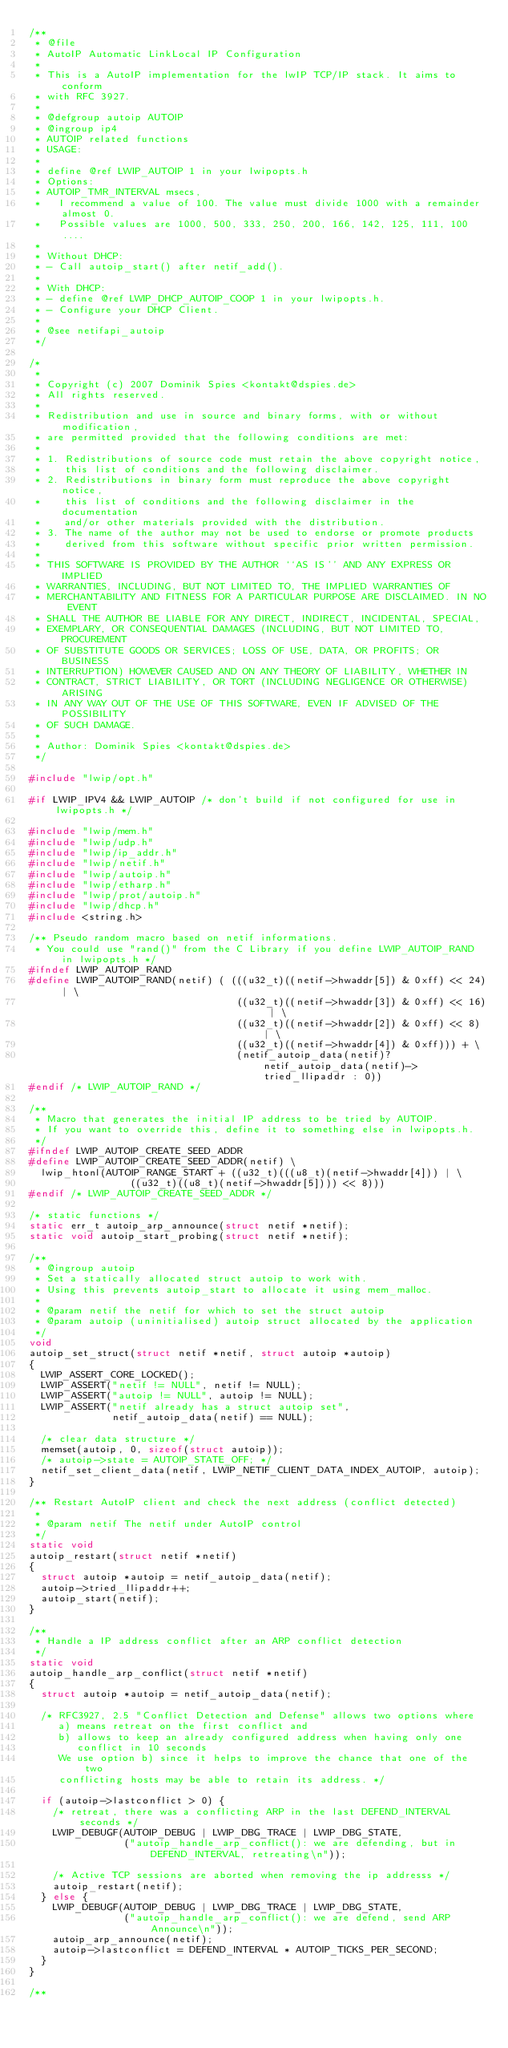<code> <loc_0><loc_0><loc_500><loc_500><_C_>/**
 * @file
 * AutoIP Automatic LinkLocal IP Configuration
 *
 * This is a AutoIP implementation for the lwIP TCP/IP stack. It aims to conform
 * with RFC 3927.
 *
 * @defgroup autoip AUTOIP
 * @ingroup ip4
 * AUTOIP related functions
 * USAGE:
 *
 * define @ref LWIP_AUTOIP 1 in your lwipopts.h
 * Options:
 * AUTOIP_TMR_INTERVAL msecs,
 *   I recommend a value of 100. The value must divide 1000 with a remainder almost 0.
 *   Possible values are 1000, 500, 333, 250, 200, 166, 142, 125, 111, 100 ....
 *
 * Without DHCP:
 * - Call autoip_start() after netif_add().
 *
 * With DHCP:
 * - define @ref LWIP_DHCP_AUTOIP_COOP 1 in your lwipopts.h.
 * - Configure your DHCP Client.
 *
 * @see netifapi_autoip
 */

/*
 *
 * Copyright (c) 2007 Dominik Spies <kontakt@dspies.de>
 * All rights reserved.
 *
 * Redistribution and use in source and binary forms, with or without modification,
 * are permitted provided that the following conditions are met:
 *
 * 1. Redistributions of source code must retain the above copyright notice,
 *    this list of conditions and the following disclaimer.
 * 2. Redistributions in binary form must reproduce the above copyright notice,
 *    this list of conditions and the following disclaimer in the documentation
 *    and/or other materials provided with the distribution.
 * 3. The name of the author may not be used to endorse or promote products
 *    derived from this software without specific prior written permission.
 *
 * THIS SOFTWARE IS PROVIDED BY THE AUTHOR ``AS IS'' AND ANY EXPRESS OR IMPLIED
 * WARRANTIES, INCLUDING, BUT NOT LIMITED TO, THE IMPLIED WARRANTIES OF
 * MERCHANTABILITY AND FITNESS FOR A PARTICULAR PURPOSE ARE DISCLAIMED. IN NO EVENT
 * SHALL THE AUTHOR BE LIABLE FOR ANY DIRECT, INDIRECT, INCIDENTAL, SPECIAL,
 * EXEMPLARY, OR CONSEQUENTIAL DAMAGES (INCLUDING, BUT NOT LIMITED TO, PROCUREMENT
 * OF SUBSTITUTE GOODS OR SERVICES; LOSS OF USE, DATA, OR PROFITS; OR BUSINESS
 * INTERRUPTION) HOWEVER CAUSED AND ON ANY THEORY OF LIABILITY, WHETHER IN
 * CONTRACT, STRICT LIABILITY, OR TORT (INCLUDING NEGLIGENCE OR OTHERWISE) ARISING
 * IN ANY WAY OUT OF THE USE OF THIS SOFTWARE, EVEN IF ADVISED OF THE POSSIBILITY
 * OF SUCH DAMAGE.
 *
 * Author: Dominik Spies <kontakt@dspies.de>
 */

#include "lwip/opt.h"

#if LWIP_IPV4 && LWIP_AUTOIP /* don't build if not configured for use in lwipopts.h */

#include "lwip/mem.h"
#include "lwip/udp.h"
#include "lwip/ip_addr.h"
#include "lwip/netif.h"
#include "lwip/autoip.h"
#include "lwip/etharp.h"
#include "lwip/prot/autoip.h"
#include "lwip/dhcp.h"
#include <string.h>

/** Pseudo random macro based on netif informations.
 * You could use "rand()" from the C Library if you define LWIP_AUTOIP_RAND in lwipopts.h */
#ifndef LWIP_AUTOIP_RAND
#define LWIP_AUTOIP_RAND(netif) ( (((u32_t)((netif->hwaddr[5]) & 0xff) << 24) | \
                                   ((u32_t)((netif->hwaddr[3]) & 0xff) << 16) | \
                                   ((u32_t)((netif->hwaddr[2]) & 0xff) << 8) | \
                                   ((u32_t)((netif->hwaddr[4]) & 0xff))) + \
                                   (netif_autoip_data(netif)? netif_autoip_data(netif)->tried_llipaddr : 0))
#endif /* LWIP_AUTOIP_RAND */

/**
 * Macro that generates the initial IP address to be tried by AUTOIP.
 * If you want to override this, define it to something else in lwipopts.h.
 */
#ifndef LWIP_AUTOIP_CREATE_SEED_ADDR
#define LWIP_AUTOIP_CREATE_SEED_ADDR(netif) \
  lwip_htonl(AUTOIP_RANGE_START + ((u32_t)(((u8_t)(netif->hwaddr[4])) | \
                 ((u32_t)((u8_t)(netif->hwaddr[5]))) << 8)))
#endif /* LWIP_AUTOIP_CREATE_SEED_ADDR */

/* static functions */
static err_t autoip_arp_announce(struct netif *netif);
static void autoip_start_probing(struct netif *netif);

/**
 * @ingroup autoip
 * Set a statically allocated struct autoip to work with.
 * Using this prevents autoip_start to allocate it using mem_malloc.
 *
 * @param netif the netif for which to set the struct autoip
 * @param autoip (uninitialised) autoip struct allocated by the application
 */
void
autoip_set_struct(struct netif *netif, struct autoip *autoip)
{
  LWIP_ASSERT_CORE_LOCKED();
  LWIP_ASSERT("netif != NULL", netif != NULL);
  LWIP_ASSERT("autoip != NULL", autoip != NULL);
  LWIP_ASSERT("netif already has a struct autoip set",
              netif_autoip_data(netif) == NULL);

  /* clear data structure */
  memset(autoip, 0, sizeof(struct autoip));
  /* autoip->state = AUTOIP_STATE_OFF; */
  netif_set_client_data(netif, LWIP_NETIF_CLIENT_DATA_INDEX_AUTOIP, autoip);
}

/** Restart AutoIP client and check the next address (conflict detected)
 *
 * @param netif The netif under AutoIP control
 */
static void
autoip_restart(struct netif *netif)
{
  struct autoip *autoip = netif_autoip_data(netif);
  autoip->tried_llipaddr++;
  autoip_start(netif);
}

/**
 * Handle a IP address conflict after an ARP conflict detection
 */
static void
autoip_handle_arp_conflict(struct netif *netif)
{
  struct autoip *autoip = netif_autoip_data(netif);

  /* RFC3927, 2.5 "Conflict Detection and Defense" allows two options where
     a) means retreat on the first conflict and
     b) allows to keep an already configured address when having only one
        conflict in 10 seconds
     We use option b) since it helps to improve the chance that one of the two
     conflicting hosts may be able to retain its address. */

  if (autoip->lastconflict > 0) {
    /* retreat, there was a conflicting ARP in the last DEFEND_INTERVAL seconds */
    LWIP_DEBUGF(AUTOIP_DEBUG | LWIP_DBG_TRACE | LWIP_DBG_STATE,
                ("autoip_handle_arp_conflict(): we are defending, but in DEFEND_INTERVAL, retreating\n"));

    /* Active TCP sessions are aborted when removing the ip addresss */
    autoip_restart(netif);
  } else {
    LWIP_DEBUGF(AUTOIP_DEBUG | LWIP_DBG_TRACE | LWIP_DBG_STATE,
                ("autoip_handle_arp_conflict(): we are defend, send ARP Announce\n"));
    autoip_arp_announce(netif);
    autoip->lastconflict = DEFEND_INTERVAL * AUTOIP_TICKS_PER_SECOND;
  }
}

/**</code> 